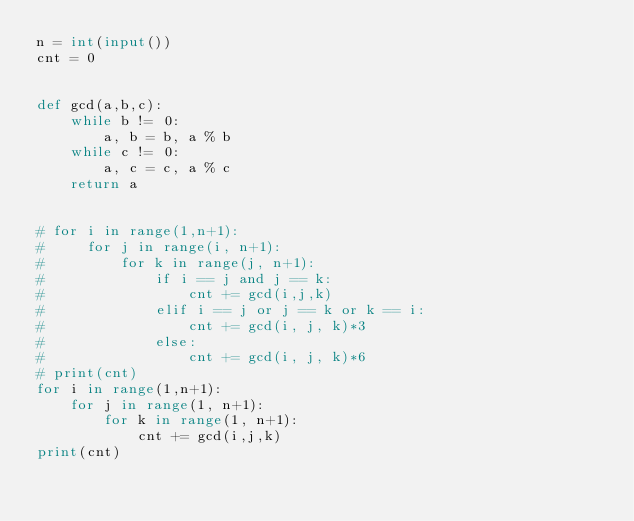Convert code to text. <code><loc_0><loc_0><loc_500><loc_500><_Python_>n = int(input())
cnt = 0


def gcd(a,b,c):
    while b != 0:
        a, b = b, a % b
    while c != 0:
        a, c = c, a % c
    return a


# for i in range(1,n+1):
#     for j in range(i, n+1):
#         for k in range(j, n+1):
#             if i == j and j == k:
#                 cnt += gcd(i,j,k)
#             elif i == j or j == k or k == i:
#                 cnt += gcd(i, j, k)*3
#             else:
#                 cnt += gcd(i, j, k)*6
# print(cnt)
for i in range(1,n+1):
    for j in range(1, n+1):
        for k in range(1, n+1):
            cnt += gcd(i,j,k)
print(cnt)


</code> 